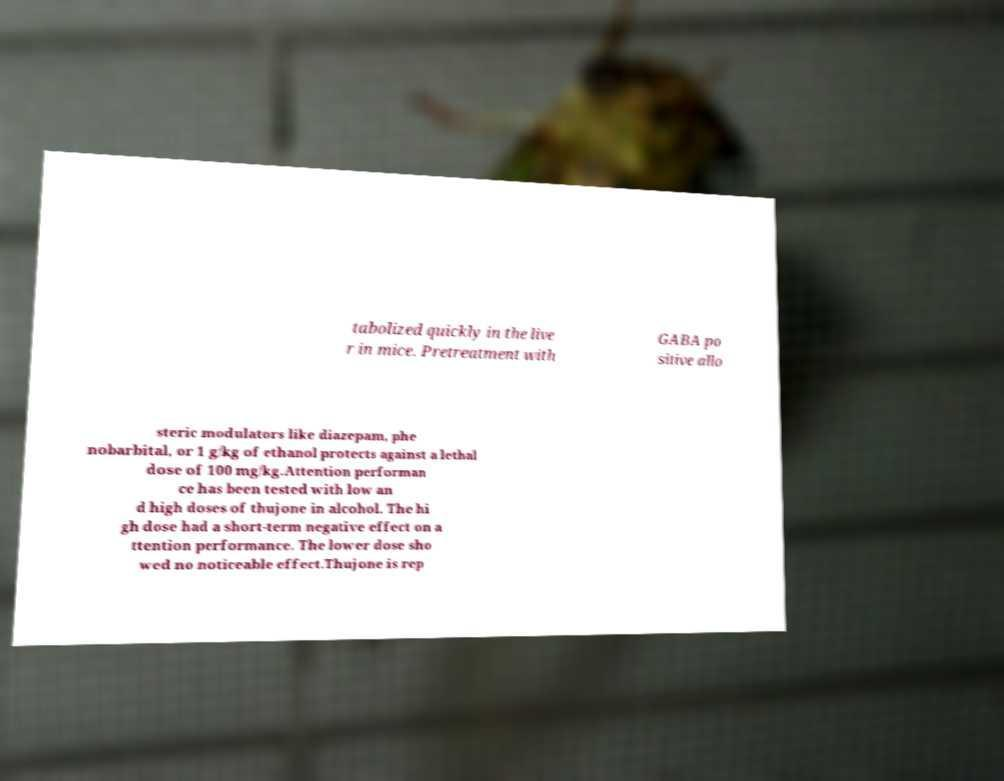Please read and relay the text visible in this image. What does it say? tabolized quickly in the live r in mice. Pretreatment with GABA po sitive allo steric modulators like diazepam, phe nobarbital, or 1 g/kg of ethanol protects against a lethal dose of 100 mg/kg.Attention performan ce has been tested with low an d high doses of thujone in alcohol. The hi gh dose had a short-term negative effect on a ttention performance. The lower dose sho wed no noticeable effect.Thujone is rep 